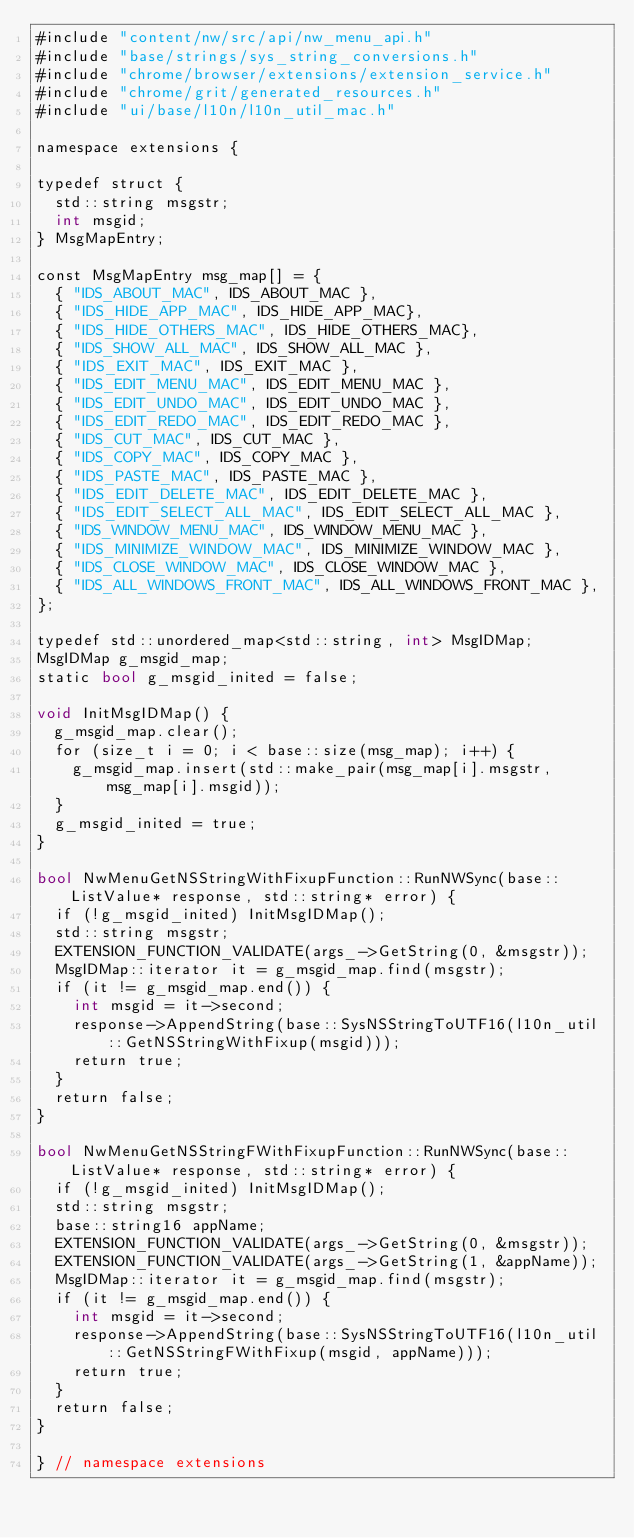<code> <loc_0><loc_0><loc_500><loc_500><_ObjectiveC_>#include "content/nw/src/api/nw_menu_api.h"
#include "base/strings/sys_string_conversions.h"
#include "chrome/browser/extensions/extension_service.h"
#include "chrome/grit/generated_resources.h"
#include "ui/base/l10n/l10n_util_mac.h"

namespace extensions {

typedef struct {
  std::string msgstr;
  int msgid;
} MsgMapEntry;

const MsgMapEntry msg_map[] = {
  { "IDS_ABOUT_MAC", IDS_ABOUT_MAC },
  { "IDS_HIDE_APP_MAC", IDS_HIDE_APP_MAC},
  { "IDS_HIDE_OTHERS_MAC", IDS_HIDE_OTHERS_MAC},
  { "IDS_SHOW_ALL_MAC", IDS_SHOW_ALL_MAC },
  { "IDS_EXIT_MAC", IDS_EXIT_MAC },
  { "IDS_EDIT_MENU_MAC", IDS_EDIT_MENU_MAC },
  { "IDS_EDIT_UNDO_MAC", IDS_EDIT_UNDO_MAC },
  { "IDS_EDIT_REDO_MAC", IDS_EDIT_REDO_MAC },
  { "IDS_CUT_MAC", IDS_CUT_MAC },
  { "IDS_COPY_MAC", IDS_COPY_MAC },
  { "IDS_PASTE_MAC", IDS_PASTE_MAC },
  { "IDS_EDIT_DELETE_MAC", IDS_EDIT_DELETE_MAC },
  { "IDS_EDIT_SELECT_ALL_MAC", IDS_EDIT_SELECT_ALL_MAC },
  { "IDS_WINDOW_MENU_MAC", IDS_WINDOW_MENU_MAC },
  { "IDS_MINIMIZE_WINDOW_MAC", IDS_MINIMIZE_WINDOW_MAC },
  { "IDS_CLOSE_WINDOW_MAC", IDS_CLOSE_WINDOW_MAC },
  { "IDS_ALL_WINDOWS_FRONT_MAC", IDS_ALL_WINDOWS_FRONT_MAC },
};

typedef std::unordered_map<std::string, int> MsgIDMap;
MsgIDMap g_msgid_map;
static bool g_msgid_inited = false;

void InitMsgIDMap() {
  g_msgid_map.clear();
  for (size_t i = 0; i < base::size(msg_map); i++) {
    g_msgid_map.insert(std::make_pair(msg_map[i].msgstr, msg_map[i].msgid));
  }
  g_msgid_inited = true;
}

bool NwMenuGetNSStringWithFixupFunction::RunNWSync(base::ListValue* response, std::string* error) {
  if (!g_msgid_inited) InitMsgIDMap();
  std::string msgstr;
  EXTENSION_FUNCTION_VALIDATE(args_->GetString(0, &msgstr));
  MsgIDMap::iterator it = g_msgid_map.find(msgstr);
  if (it != g_msgid_map.end()) {
    int msgid = it->second;
    response->AppendString(base::SysNSStringToUTF16(l10n_util::GetNSStringWithFixup(msgid)));
    return true;
  }
  return false;
}

bool NwMenuGetNSStringFWithFixupFunction::RunNWSync(base::ListValue* response, std::string* error) {
  if (!g_msgid_inited) InitMsgIDMap();
  std::string msgstr;
  base::string16 appName;
  EXTENSION_FUNCTION_VALIDATE(args_->GetString(0, &msgstr));
  EXTENSION_FUNCTION_VALIDATE(args_->GetString(1, &appName));
  MsgIDMap::iterator it = g_msgid_map.find(msgstr);
  if (it != g_msgid_map.end()) {
    int msgid = it->second;
    response->AppendString(base::SysNSStringToUTF16(l10n_util::GetNSStringFWithFixup(msgid, appName)));
    return true;
  }
  return false;
}

} // namespace extensions
</code> 